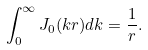<formula> <loc_0><loc_0><loc_500><loc_500>\int _ { 0 } ^ { \infty } J _ { 0 } ( k r ) d k = \frac { 1 } { r } .</formula> 